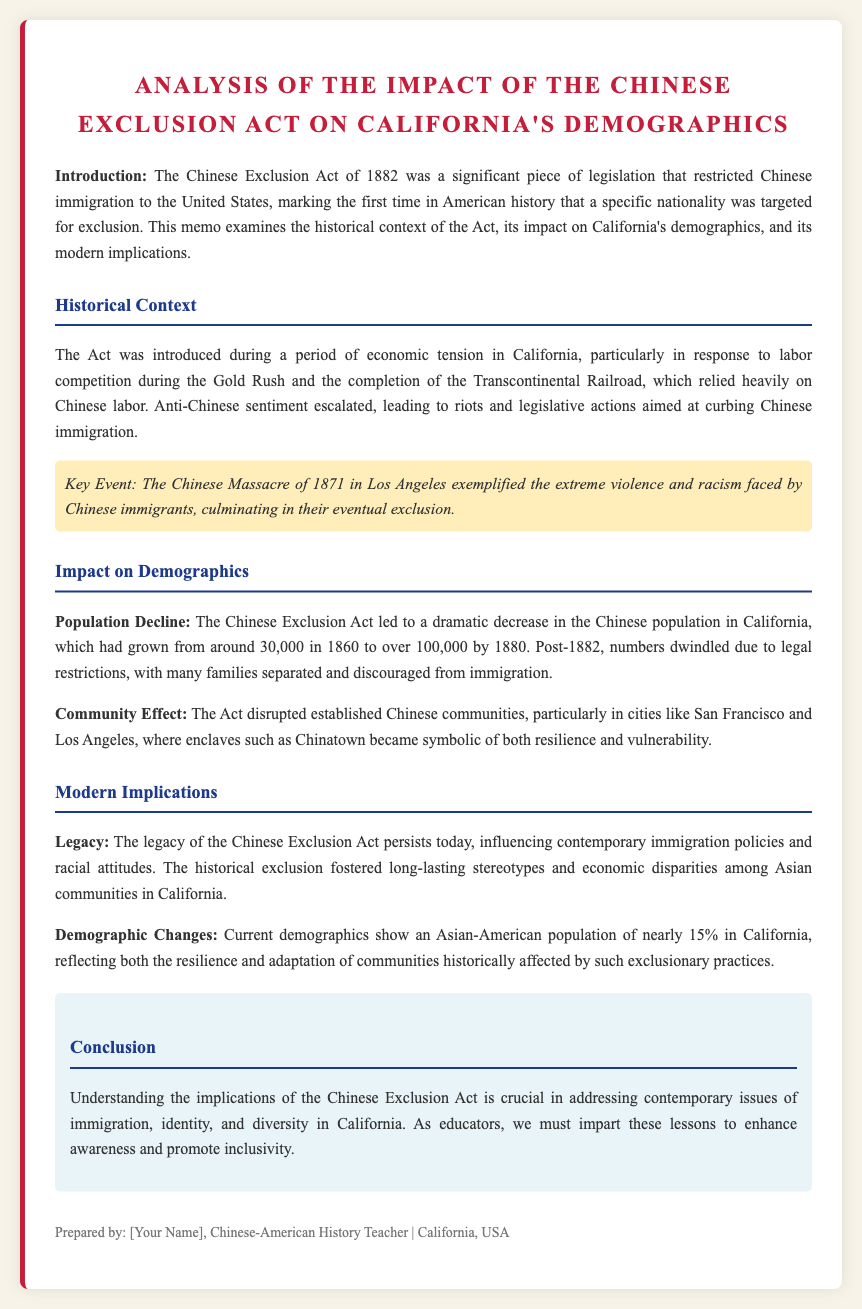What year was the Chinese Exclusion Act enacted? The document states that the Chinese Exclusion Act was introduced in 1882.
Answer: 1882 What was the Chinese population in California around 1860? The document mentions that the Chinese population in California was around 30,000 in 1860.
Answer: 30,000 Which city became symbolic of both resilience and vulnerability for Chinese communities? The document mentions that cities like San Francisco and Los Angeles became symbolic, particularly Chinatown.
Answer: Chinatown What major event exemplified the violence faced by Chinese immigrants? The document highlights the Chinese Massacre of 1871 as an extreme example of violence faced.
Answer: Chinese Massacre of 1871 What percentage of California's population is Asian-American today? The document states that the current Asian-American population in California is nearly 15%.
Answer: 15% Why is it essential to understand the Chinese Exclusion Act's implications? The document emphasizes that understanding its implications is crucial for addressing contemporary issues of immigration, identity, and diversity.
Answer: Addressing contemporary issues What was a significant legislation in American history regarding immigration? The document refers to the Chinese Exclusion Act as the first significant legislation that targeted a nationality for exclusion.
Answer: Chinese Exclusion Act What labor situation in California led to the introduction of the Exclusion Act? The document discusses economic tension related to labor competition during the Gold Rush and the Transcontinental Railroad completion.
Answer: Labor competition What does the conclusion suggest educators must do regarding the Chinese Exclusion Act? The conclusion suggests that educators must impart lessons to enhance awareness and promote inclusivity.
Answer: Promote inclusivity 